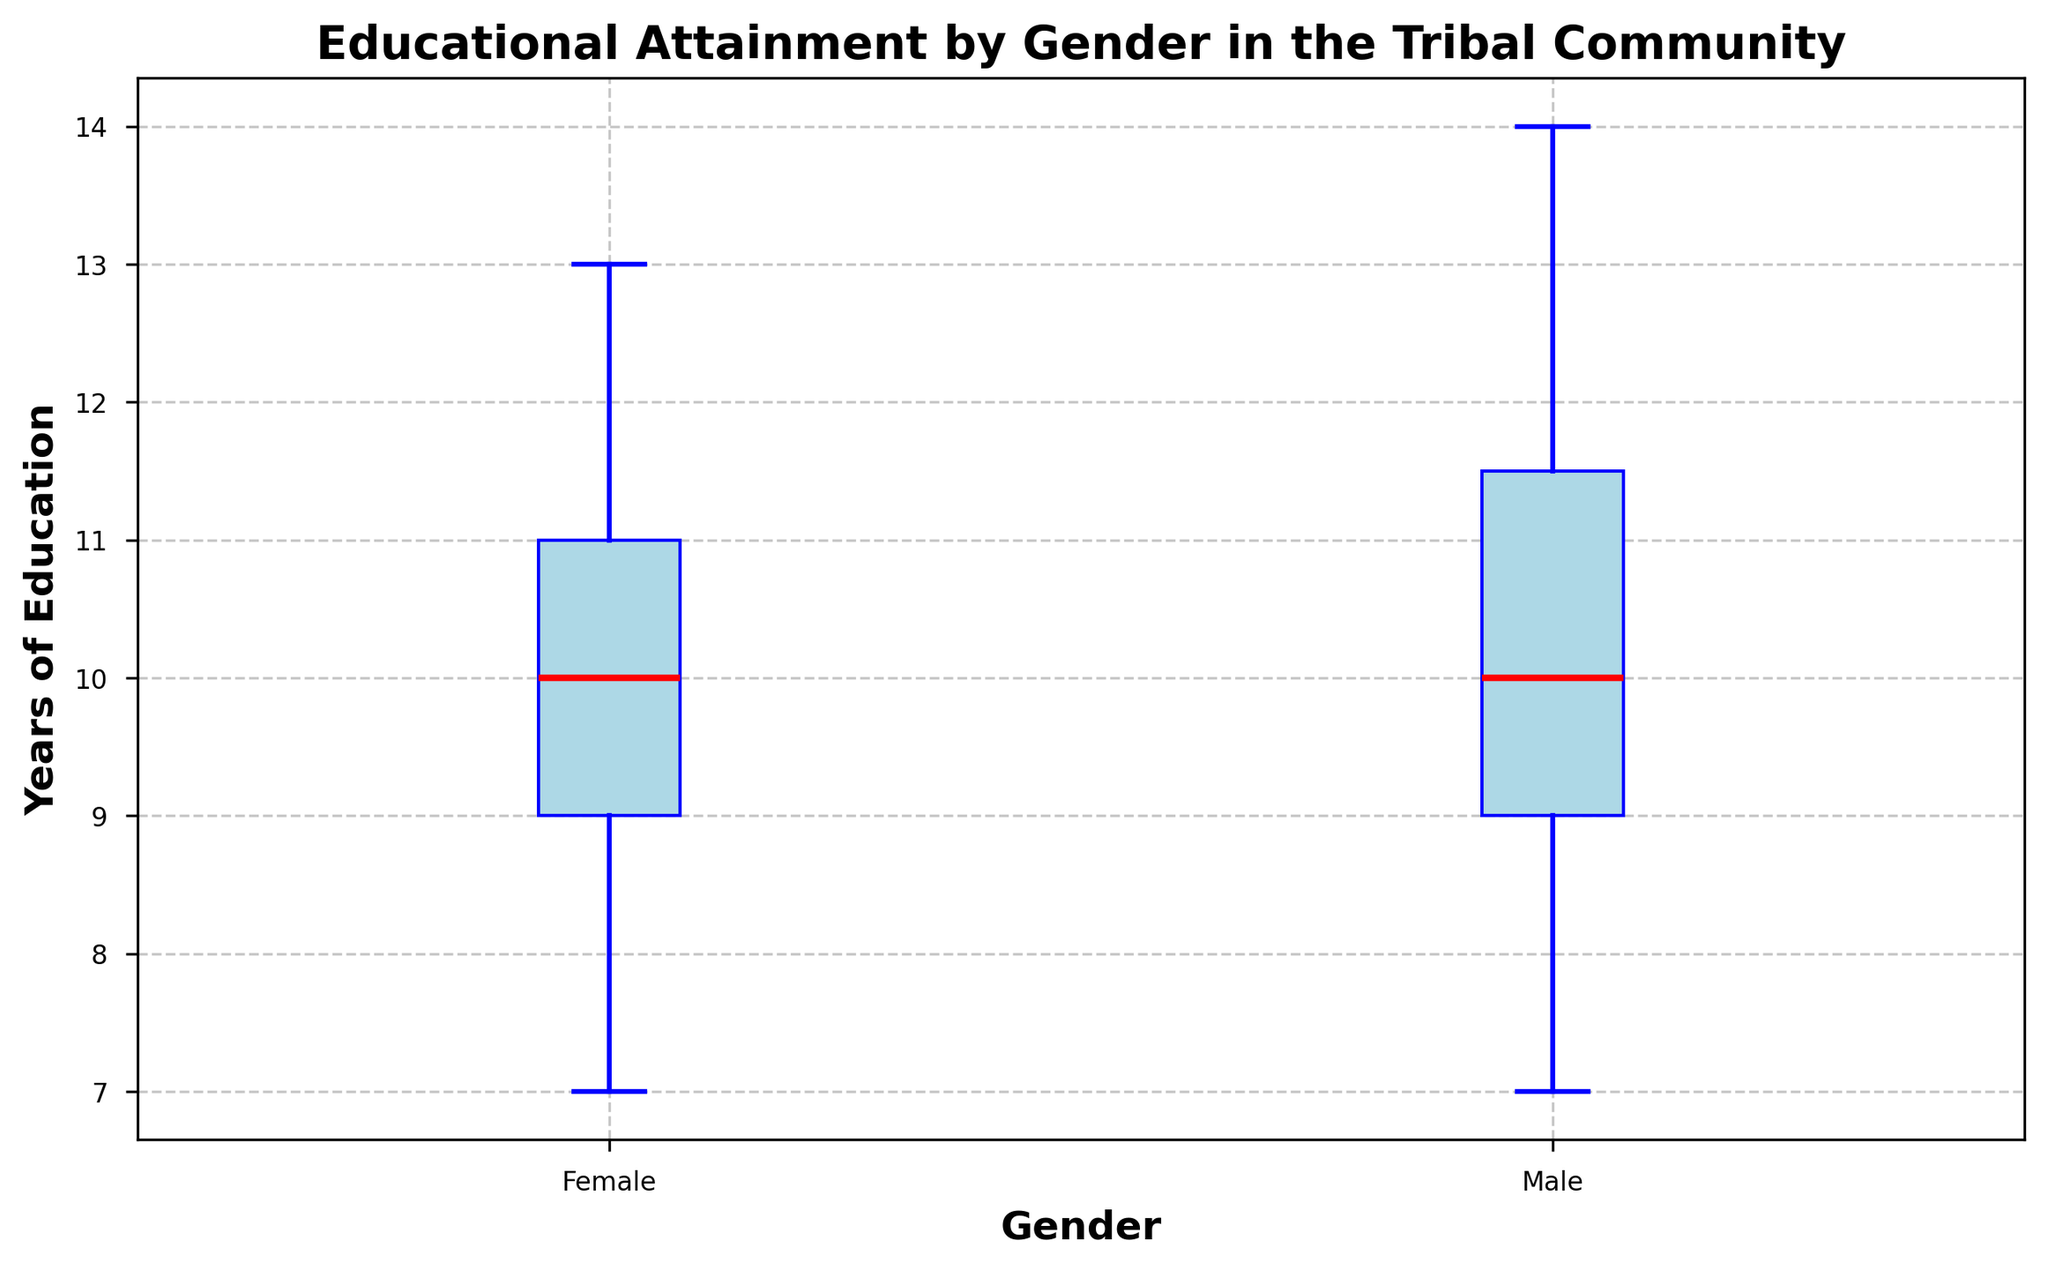What is the median educational attainment for males? To find the median, locate the middle value in the sorted list of the male group's educational attainment. In the box plot, this is represented by the red line within the blue box for males.
Answer: 10.5 years What is the range of educational attainment for females? The range is calculated by subtracting the minimum value from the maximum value within the female group's educational attainment. In the box plot, this is the distance between the bottom and top whiskers of the female group.
Answer: 6 years Which gender has a higher median educational attainment? Compare the red lines within the blue boxes for each gender. The line representing the median for females is slightly higher than for males.
Answer: Female Are there any outliers in the educational attainment for males? Outliers are represented by specific markers outside the whiskers. Visually inspect the male group's box plot for any such markers.
Answer: No What is the interquartile range (IQR) for females? The IQR is the distance between the first quartile (Q1) and the third quartile (Q3). In the box plot, these are the lower and upper edges of the blue box for the female group. Calculate the difference between these quartiles.
Answer: 3 years What is the difference in the median values of educational attainment between males and females? Subtract the median educational attainment for males from that for females. This can be identified by the position of the red lines within the boxes for each gender.
Answer: 0.5 years Which gender shows greater variability in educational attainment? Variability can be inferred by observing the overall spread of the whiskers and the size of the box for each gender. The male group seems to have a larger spread.
Answer: Male What is the minimum educational attainment for both males and females? Identify the bottom whisker for each gender's box plot. This represents the minimum educational attainment within each gender group.
Answer: 7 years for both What are the third quartile values for males and females? For each gender's box plot, the third quartile (Q3) is the Upper edge of the blue box. This value indicates the educational attainment level below which 75% of the data falls.
Answer: Males: 12 years, Females: 12 years Is the distribution of educational attainment symmetric for either gender? Symmetry in the distribution can be inferred by comparing the position of the median relative to the quartiles and the overall shape of the boxes and whiskers. Neither gender has a perfectly symmetric distribution as indicated by the box and whisker lengths.
Answer: No 